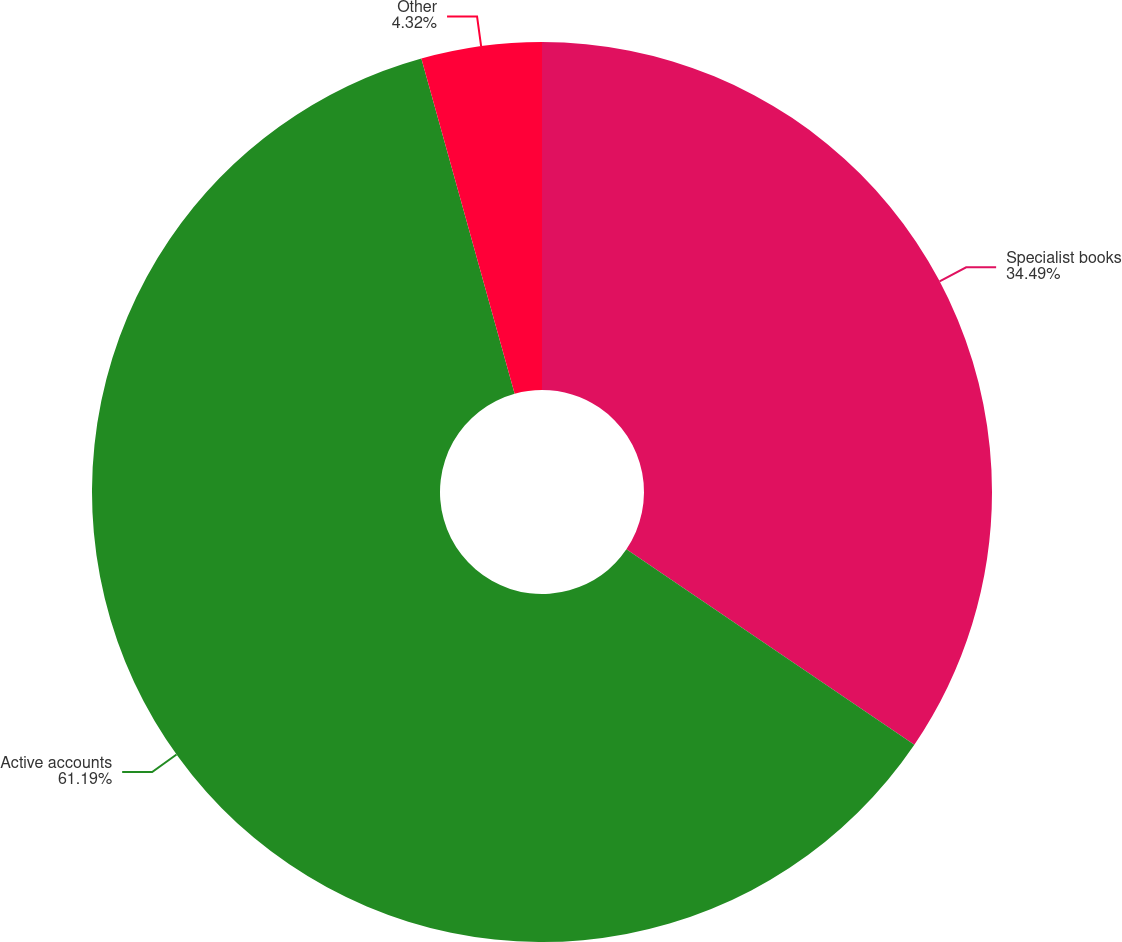Convert chart to OTSL. <chart><loc_0><loc_0><loc_500><loc_500><pie_chart><fcel>Specialist books<fcel>Active accounts<fcel>Other<nl><fcel>34.49%<fcel>61.19%<fcel>4.32%<nl></chart> 